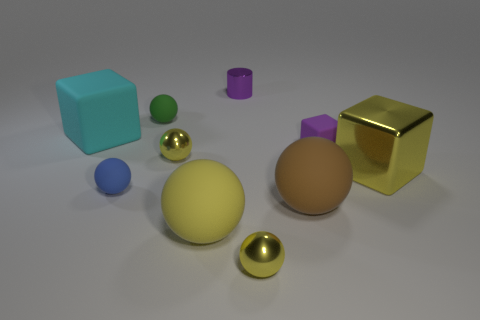What number of objects are tiny matte cubes on the left side of the yellow block or balls that are in front of the large cyan cube?
Make the answer very short. 6. Is the color of the cylinder the same as the tiny cube?
Offer a terse response. Yes. Are there fewer tiny blue cubes than brown rubber spheres?
Offer a terse response. Yes. Are there any large blocks on the right side of the small purple shiny cylinder?
Ensure brevity in your answer.  Yes. Does the tiny green sphere have the same material as the purple cube?
Make the answer very short. Yes. There is a metallic thing that is the same shape as the big cyan matte object; what is its color?
Your answer should be compact. Yellow. Is the color of the rubber ball that is behind the yellow cube the same as the small metal cylinder?
Your answer should be compact. No. There is a rubber object that is the same color as the shiny cube; what is its shape?
Your answer should be compact. Sphere. How many small spheres are made of the same material as the big yellow cube?
Your response must be concise. 2. How many tiny metal objects are to the left of the large brown rubber sphere?
Offer a very short reply. 3. 